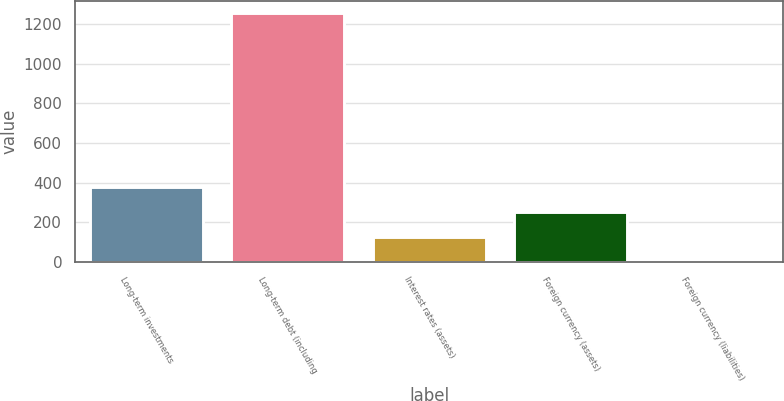Convert chart. <chart><loc_0><loc_0><loc_500><loc_500><bar_chart><fcel>Long-term investments<fcel>Long-term debt (including<fcel>Interest rates (assets)<fcel>Foreign currency (assets)<fcel>Foreign currency (liabilities)<nl><fcel>377.35<fcel>1256.2<fcel>126.25<fcel>251.8<fcel>0.7<nl></chart> 